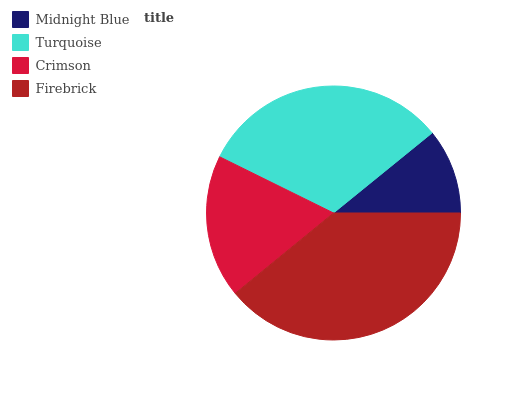Is Midnight Blue the minimum?
Answer yes or no. Yes. Is Firebrick the maximum?
Answer yes or no. Yes. Is Turquoise the minimum?
Answer yes or no. No. Is Turquoise the maximum?
Answer yes or no. No. Is Turquoise greater than Midnight Blue?
Answer yes or no. Yes. Is Midnight Blue less than Turquoise?
Answer yes or no. Yes. Is Midnight Blue greater than Turquoise?
Answer yes or no. No. Is Turquoise less than Midnight Blue?
Answer yes or no. No. Is Turquoise the high median?
Answer yes or no. Yes. Is Crimson the low median?
Answer yes or no. Yes. Is Firebrick the high median?
Answer yes or no. No. Is Firebrick the low median?
Answer yes or no. No. 